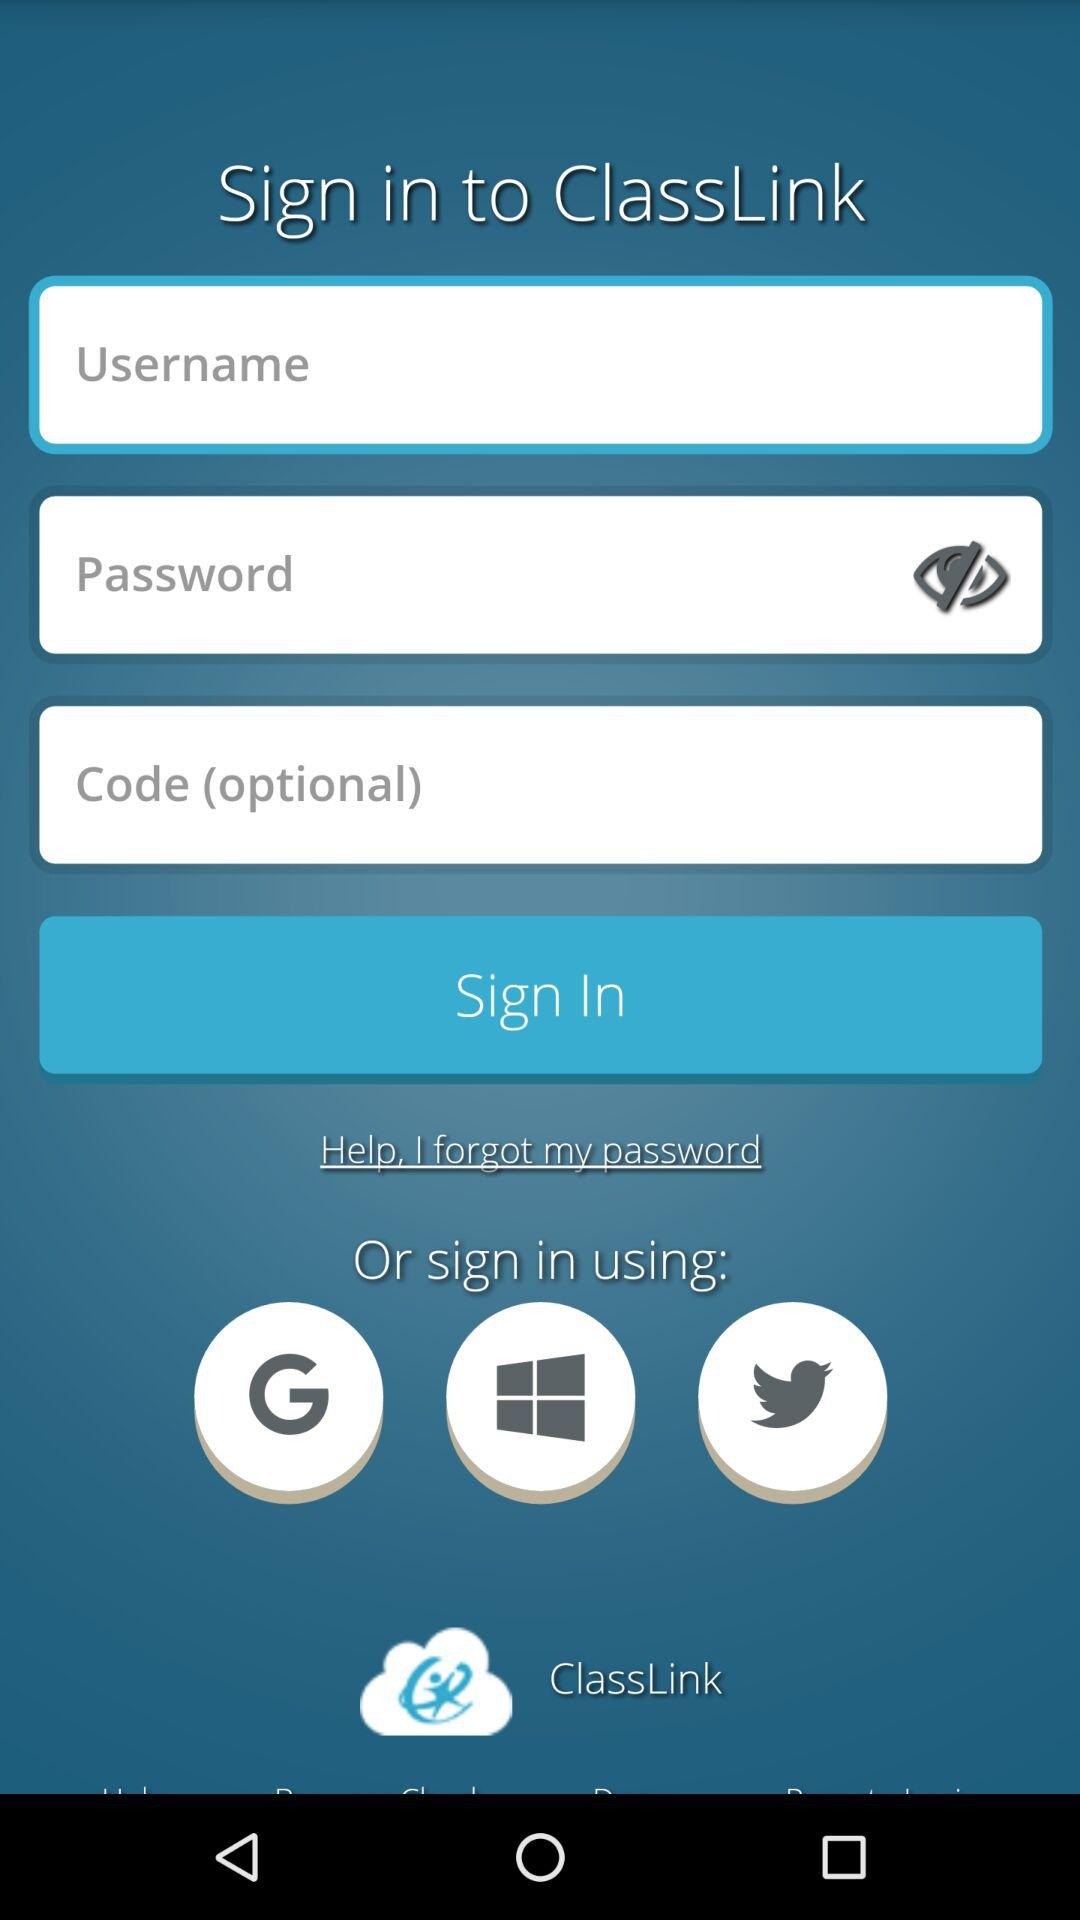What is the app name? The app name is "ClassLink". 